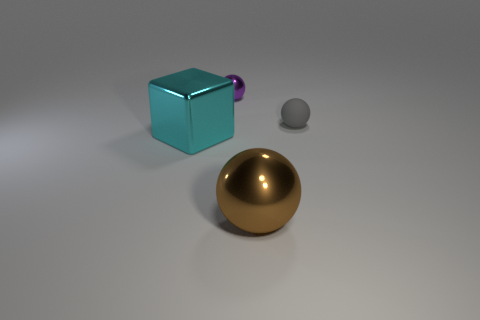Add 4 large brown matte balls. How many objects exist? 8 Subtract all purple metallic spheres. How many spheres are left? 2 Subtract all gray spheres. How many spheres are left? 2 Subtract 1 cubes. How many cubes are left? 0 Subtract all brown rubber spheres. Subtract all big brown objects. How many objects are left? 3 Add 3 small balls. How many small balls are left? 5 Add 2 big cyan objects. How many big cyan objects exist? 3 Subtract 0 purple cylinders. How many objects are left? 4 Subtract all balls. How many objects are left? 1 Subtract all brown cubes. Subtract all gray spheres. How many cubes are left? 1 